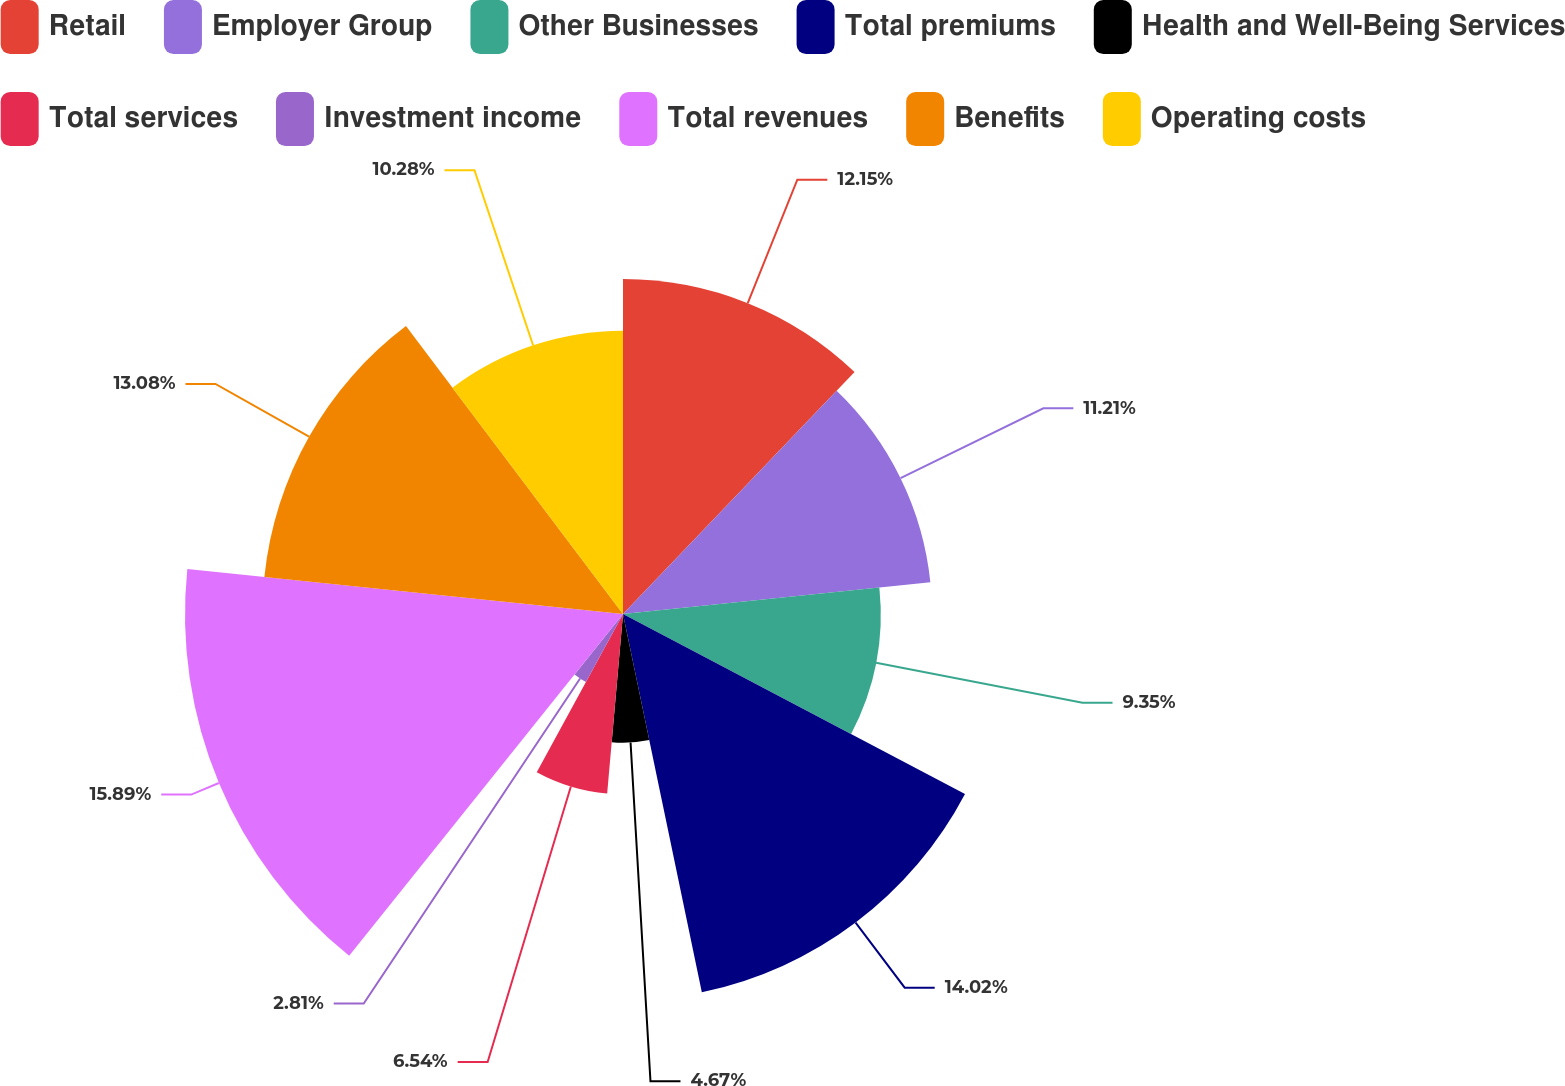Convert chart. <chart><loc_0><loc_0><loc_500><loc_500><pie_chart><fcel>Retail<fcel>Employer Group<fcel>Other Businesses<fcel>Total premiums<fcel>Health and Well-Being Services<fcel>Total services<fcel>Investment income<fcel>Total revenues<fcel>Benefits<fcel>Operating costs<nl><fcel>12.15%<fcel>11.21%<fcel>9.35%<fcel>14.02%<fcel>4.67%<fcel>6.54%<fcel>2.81%<fcel>15.89%<fcel>13.08%<fcel>10.28%<nl></chart> 